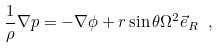Convert formula to latex. <formula><loc_0><loc_0><loc_500><loc_500>\frac { 1 } { \rho } \nabla p = - \nabla \phi + r \sin \theta \Omega ^ { 2 } \vec { e } _ { R } \ ,</formula> 